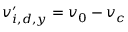Convert formula to latex. <formula><loc_0><loc_0><loc_500><loc_500>v _ { i , d , y } ^ { \prime } = v _ { 0 } - v _ { c }</formula> 